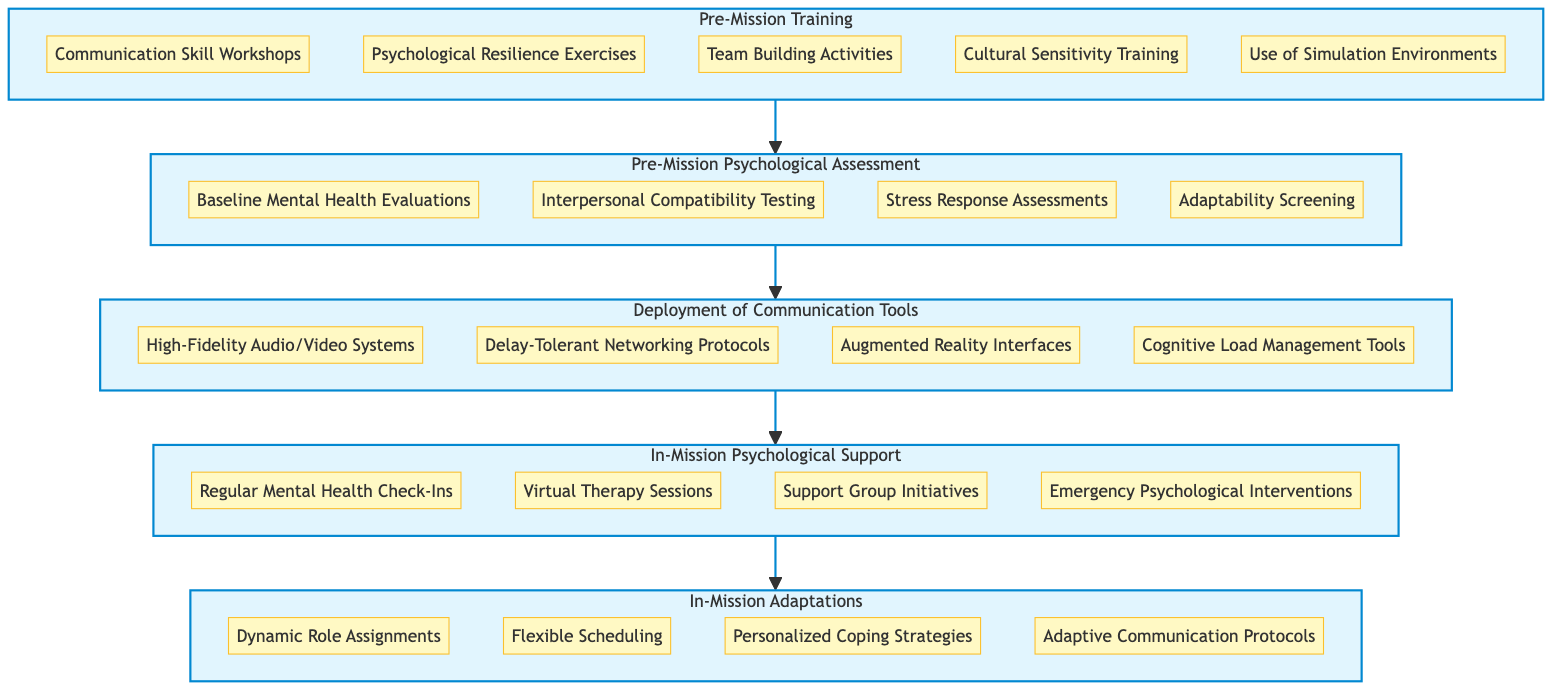What is the first level in the diagram? The diagram starts with "Pre-Mission Training" as the first level, indicating the initial stage before the mission.
Answer: Pre-Mission Training How many components are listed under "In-Mission Adaptations"? There are four components listed under "In-Mission Adaptations," which indicates the tasks or strategies related to adaptation during the mission.
Answer: Four Which level comes after "Deployment of Communication Tools"? In the flow of the diagram, "In-Mission Psychological Support" follows "Deployment of Communication Tools," indicating the next stage of communication after tools are deployed.
Answer: In-Mission Psychological Support What psychological support methods are included in the fourth level? The fourth level includes four components related to psychological support: Regular Mental Health Check-Ins, Virtual Therapy Sessions, Support Group Initiatives, and Emergency Psychological Interventions, showing options for helping astronauts in their emotional health.
Answer: Regular Mental Health Check-Ins, Virtual Therapy Sessions, Support Group Initiatives, Emergency Psychological Interventions Which training component bears the significance of adaptability in team dynamics? "Interpersonal Compatibility Testing" assesses the dynamics among crew members, aiding in understanding adaptability in relationships which is key for teamwork during missions.
Answer: Interpersonal Compatibility Testing What is the last level in the flow chart? The last level at the top of the flow chart is "In-Mission Adaptations," which represents the culmination of all the previous training and support strategies implemented.
Answer: In-Mission Adaptations Identify the relationship between "Pre-Mission Psychological Assessment" and "Deployment of Communication Tools". The "Pre-Mission Psychological Assessment" is a prerequisite for understanding the psychological needs of astronauts and sets the foundation for the "Deployment of Communication Tools," ensuring tools are tailored to the crew's needs.
Answer: Pre-Mission Psychological Assessment leads to Deployment of Communication Tools How many total levels are represented in the diagram? The diagram consists of five distinct levels, with each representing a different phase in the process of ensuring effective communication during missions.
Answer: Five Which component indicates technological integration in communication? "Augmented Reality Interfaces" represent a technological integration that enhances communication between astronauts and mission control, indicating the use of advanced technology for better interaction.
Answer: Augmented Reality Interfaces 